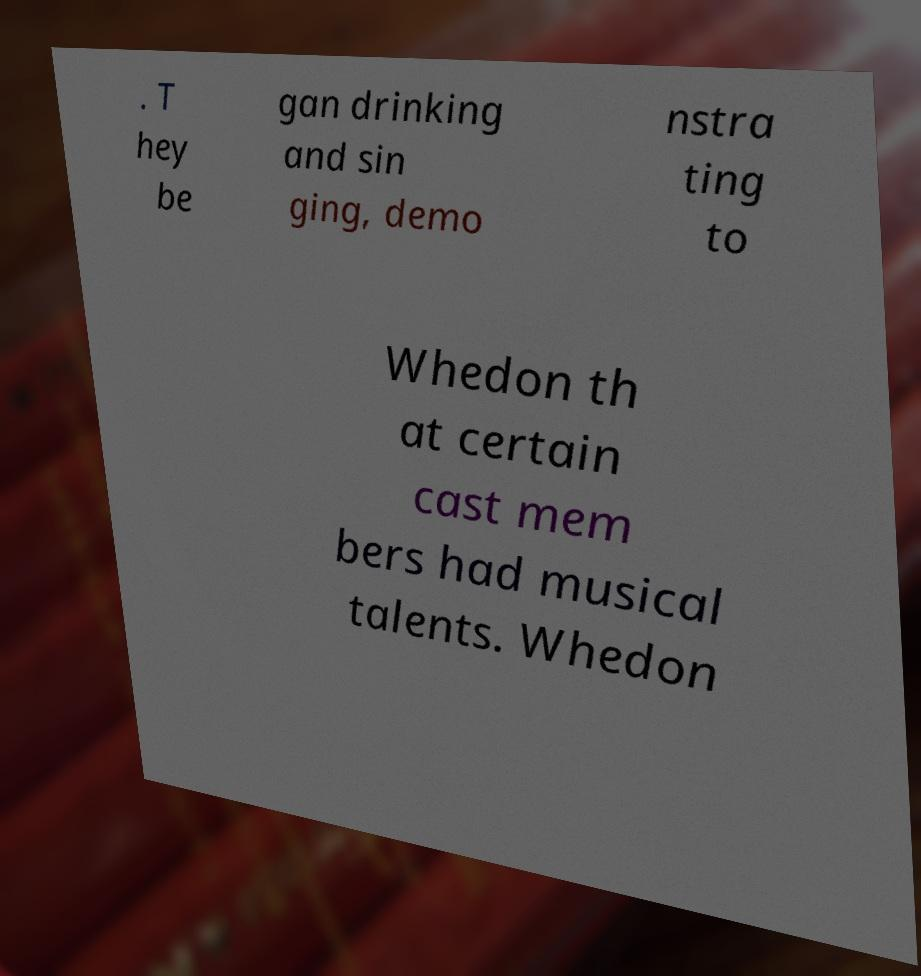Can you read and provide the text displayed in the image?This photo seems to have some interesting text. Can you extract and type it out for me? . T hey be gan drinking and sin ging, demo nstra ting to Whedon th at certain cast mem bers had musical talents. Whedon 